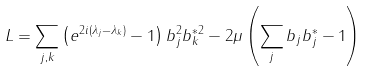<formula> <loc_0><loc_0><loc_500><loc_500>L = \sum _ { j , k } \left ( e ^ { 2 i ( \lambda _ { j } - \lambda _ { k } ) } - 1 \right ) b _ { j } ^ { 2 } b _ { k } ^ { * 2 } - 2 \mu \left ( \sum _ { j } b _ { j } b _ { j } ^ { * } - 1 \right )</formula> 